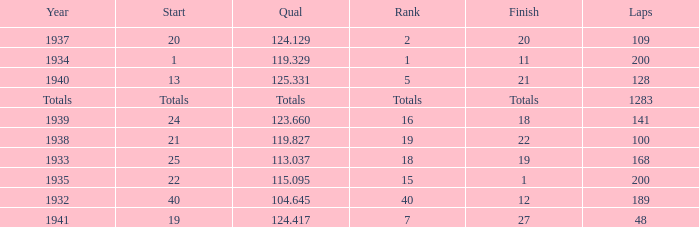Help me parse the entirety of this table. {'header': ['Year', 'Start', 'Qual', 'Rank', 'Finish', 'Laps'], 'rows': [['1937', '20', '124.129', '2', '20', '109'], ['1934', '1', '119.329', '1', '11', '200'], ['1940', '13', '125.331', '5', '21', '128'], ['Totals', 'Totals', 'Totals', 'Totals', 'Totals', '1283'], ['1939', '24', '123.660', '16', '18', '141'], ['1938', '21', '119.827', '19', '22', '100'], ['1933', '25', '113.037', '18', '19', '168'], ['1935', '22', '115.095', '15', '1', '200'], ['1932', '40', '104.645', '40', '12', '189'], ['1941', '19', '124.417', '7', '27', '48']]} What year did he start at 13? 1940.0. 